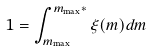Convert formula to latex. <formula><loc_0><loc_0><loc_500><loc_500>1 = \int _ { m _ { \max } } ^ { m _ { \max } * } \xi ( m ) d m</formula> 